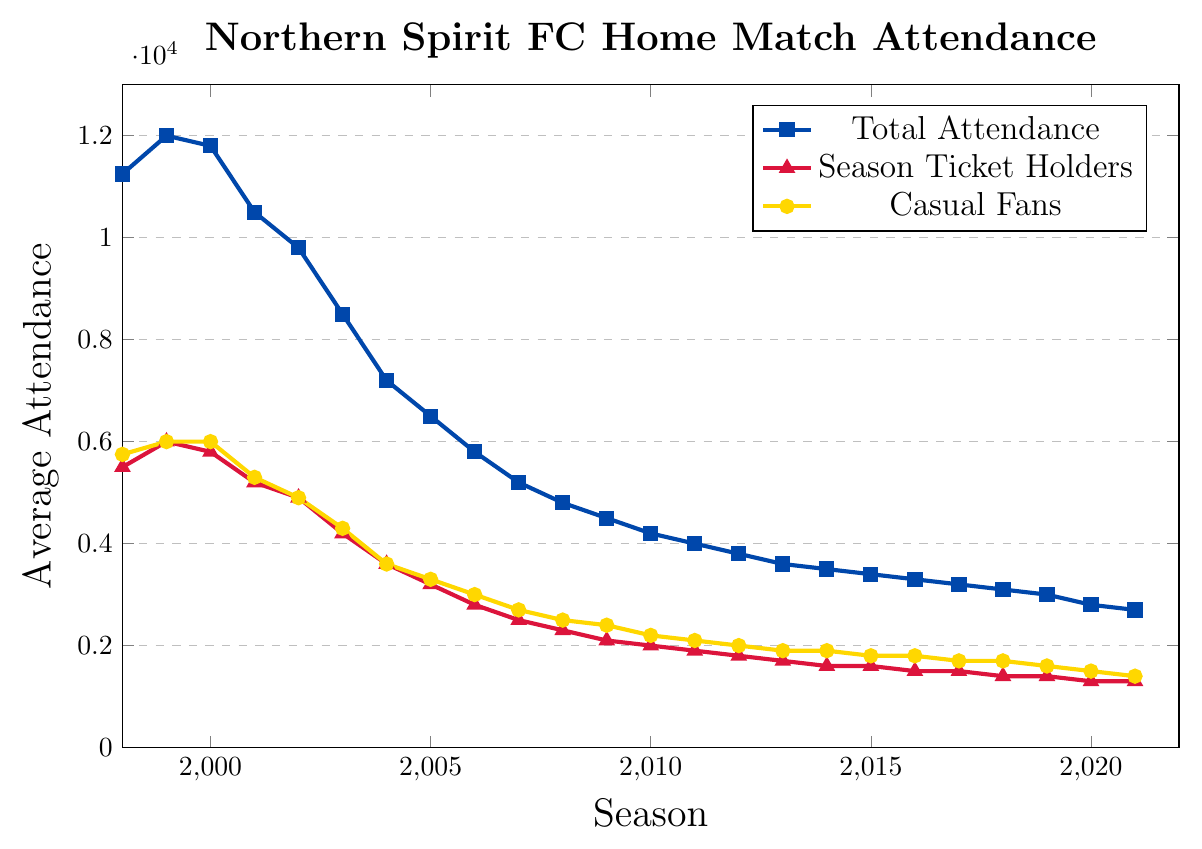What's the highest total attendance recorded in a season? To find the highest total attendance, look for the tallest line segment for "Total Attendance" on the y-axis. The highest line position belongs to 1999-00 season with around 12000 on the y-axis.
Answer: 12000 Which season had the lowest attendance for casual fans? To determine the lowest attendance for casual fans, find the lowest point on the "Casual Fans" line. The lowest point appears to be at the 2021-22 season with around 1400 casual fans.
Answer: 1400 In which season did the number of season ticket holders remain the same as the previous year? Look for spots on the "Season Ticket Holders" line where two consecutive seasons share the same y-axis value. For example, between the 2014-15 and 2015-16 seasons, the values are both around 1600.
Answer: 2015-16 What is the difference in total attendance between the 1998-99 and 2002-03 seasons? Find the total attendance values for the two seasons on the y-axis. For 1998-99, it is about 11250, and for 2002-03, it is about 9800. Then, subtract 9800 from 11250 to find the difference.
Answer: 1450 How did the average total attendance change from 2000-01 to 2001-02? Look at the "Total Attendance" line for these two seasons. The value for 2000-01 is about 11800, and for 2001-02, it is around 10500. The change is a decrease of about 1300.
Answer: 1300 decrease Which group showed a more constant decline from 1998-99 to 2021-22, season ticket holders or casual fans? Evaluate the slopes of the "Season Ticket Holders" and "Casual Fans" lines over the whole period. The "Season Ticket Holders" line shows a more steady and consistent downward trend compared to "Casual Fans", which displays more fluctuations.
Answer: Season ticket holders What's the average number of season ticket holders over the first five seasons (1998-2003)? Sum the y-axis values for "Season Ticket Holders" from 1998 to 2003, which are 5500, 6000, 5800, 5200, 4900. Then average them: (5500 + 6000 + 5800 + 5200 + 4900) / 5 = 5480.
Answer: 5480 Compare the average number of casual fans in the first five seasons with the last five seasons. Is there a noticeable pattern? First, calculate the average for the first five seasons (5750, 6000, 6000, 5300, 4900) and the last five seasons (1700, 1600, 1500, 1400, 1400). 
Average first five: (5750+6000+6000+5300+4900)/5 = 5590. 
Average last five: (1700+1600+1500+1400+1400)/5 = 1520.
The average number of casual fans has decreased over time.
Answer: Decrease Which visual element represents the number of casual fans? Identify the color and shape of the line representing casual fans. It is the yellow line with circular markers.
Answer: Yellow line with circular markers 